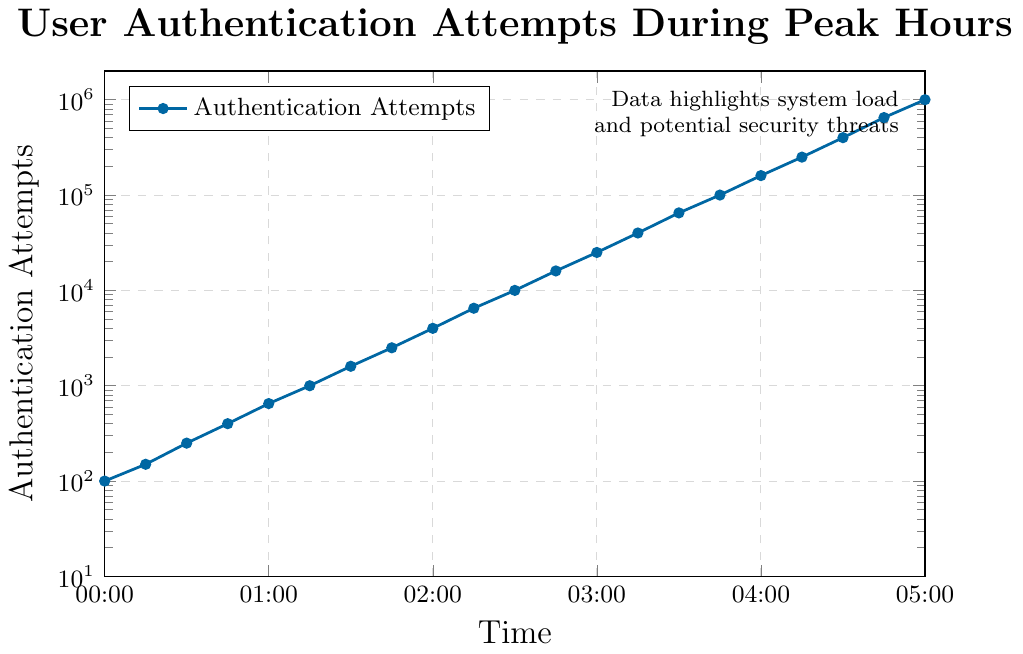When does the number of authentication attempts per second first exceed 1000? Look at the data points along the x-axis and find when the y-coordinate first surpasses 1000. This occurs at 01:15.
Answer: 01:15 How many times greater is the highest peak compared to the lowest recorded value in the chart? The lowest value is 100 at 00:00, and the highest is 1000000 at 05:00. The ratio is 1000000 / 100 = 10000.
Answer: 10000 What is the average number of authentication attempts per second at 01:00, 02:00, and 03:00? The values at 01:00, 02:00, and 03:00 are 650, 4000, and 25000 respectively. The average is (650 + 4000 + 25000) / 3.
Answer: 9867 Is the increase in authentication attempts more rapid in the first half or the second half of the observed time period? Compare the growth from 00:00 to 02:30 with 02:30 to 05:00. In the first half, it grows from 100 to 10000, a factor of 100. In the second half, it grows from 10000 to 1000000, a factor of 100.
Answer: Both are equal At what time do the authentication attempts first reach 100000? Find the time corresponding to the y-value of 100000. This happens at 03:45.
Answer: 03:45 How does the number of authentication attempts change from 02:00 to 04:00? The values at 02:00 and 04:00 are 4000 and 160000 respectively. Calculate the ratio: 160000 / 4000 = 40.
Answer: Increases by a factor of 40 Which period shows the steepest increase in authentication attempts? Identify the steepest segment by comparing changes over equivalent periods. The increase from 04:45 to 05:00 is from 650000 to 1000000.
Answer: 04:45 to 05:00 Is the system's load depicted by the number of attempts doubling in equal intervals? Observing intervals shows exponential growth rather than doubling at consistent intervals.
Answer: No What is the exponential growth factor between 03:00 and 05:00? Values at 03:00 and 05:00 are 25000 and 1000000. Calculate the ratio: 1000000 / 25000 = 40.
Answer: 40 At what time do the authentication attempts surpass 50000? Check the data points and values. This occurs first at 03:30.
Answer: 03:30 